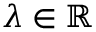Convert formula to latex. <formula><loc_0><loc_0><loc_500><loc_500>\lambda \in \mathbb { R }</formula> 